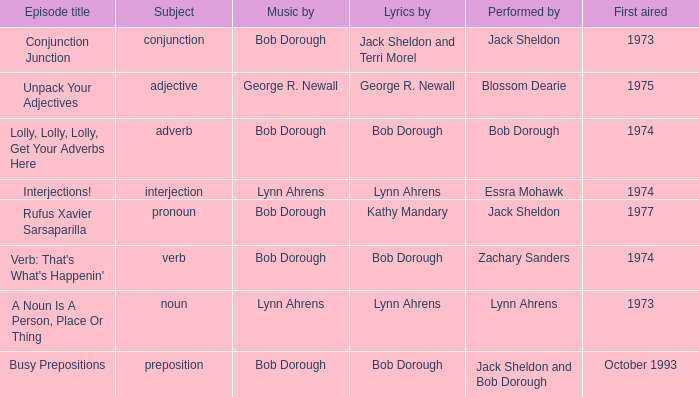When interjection is the subject who are the lyrics by? Lynn Ahrens. 